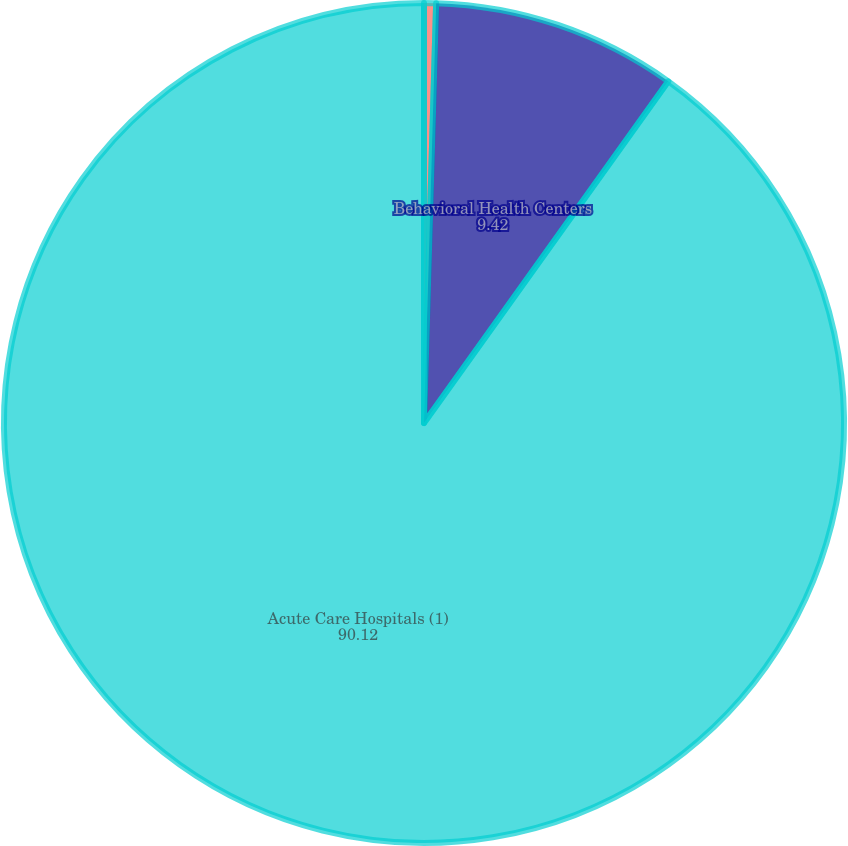<chart> <loc_0><loc_0><loc_500><loc_500><pie_chart><fcel>Acute Care Hospitals<fcel>Behavioral Health Centers<fcel>Acute Care Hospitals (1)<nl><fcel>0.46%<fcel>9.42%<fcel>90.12%<nl></chart> 